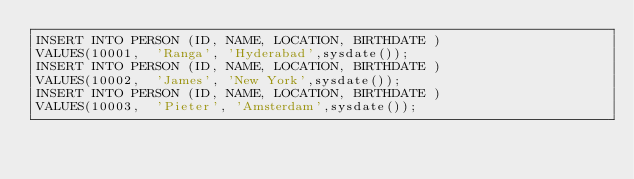Convert code to text. <code><loc_0><loc_0><loc_500><loc_500><_SQL_>INSERT INTO PERSON (ID, NAME, LOCATION, BIRTHDATE ) 
VALUES(10001,  'Ranga', 'Hyderabad',sysdate());
INSERT INTO PERSON (ID, NAME, LOCATION, BIRTHDATE ) 
VALUES(10002,  'James', 'New York',sysdate());
INSERT INTO PERSON (ID, NAME, LOCATION, BIRTHDATE ) 
VALUES(10003,  'Pieter', 'Amsterdam',sysdate());</code> 